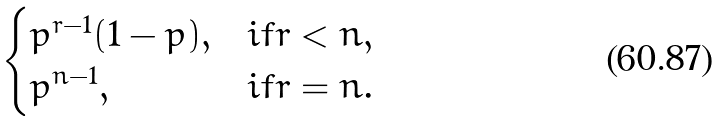Convert formula to latex. <formula><loc_0><loc_0><loc_500><loc_500>\begin{cases} p ^ { r - 1 } ( 1 - p ) , & i f r < n , \\ p ^ { n - 1 } , & i f r = n . \end{cases}</formula> 